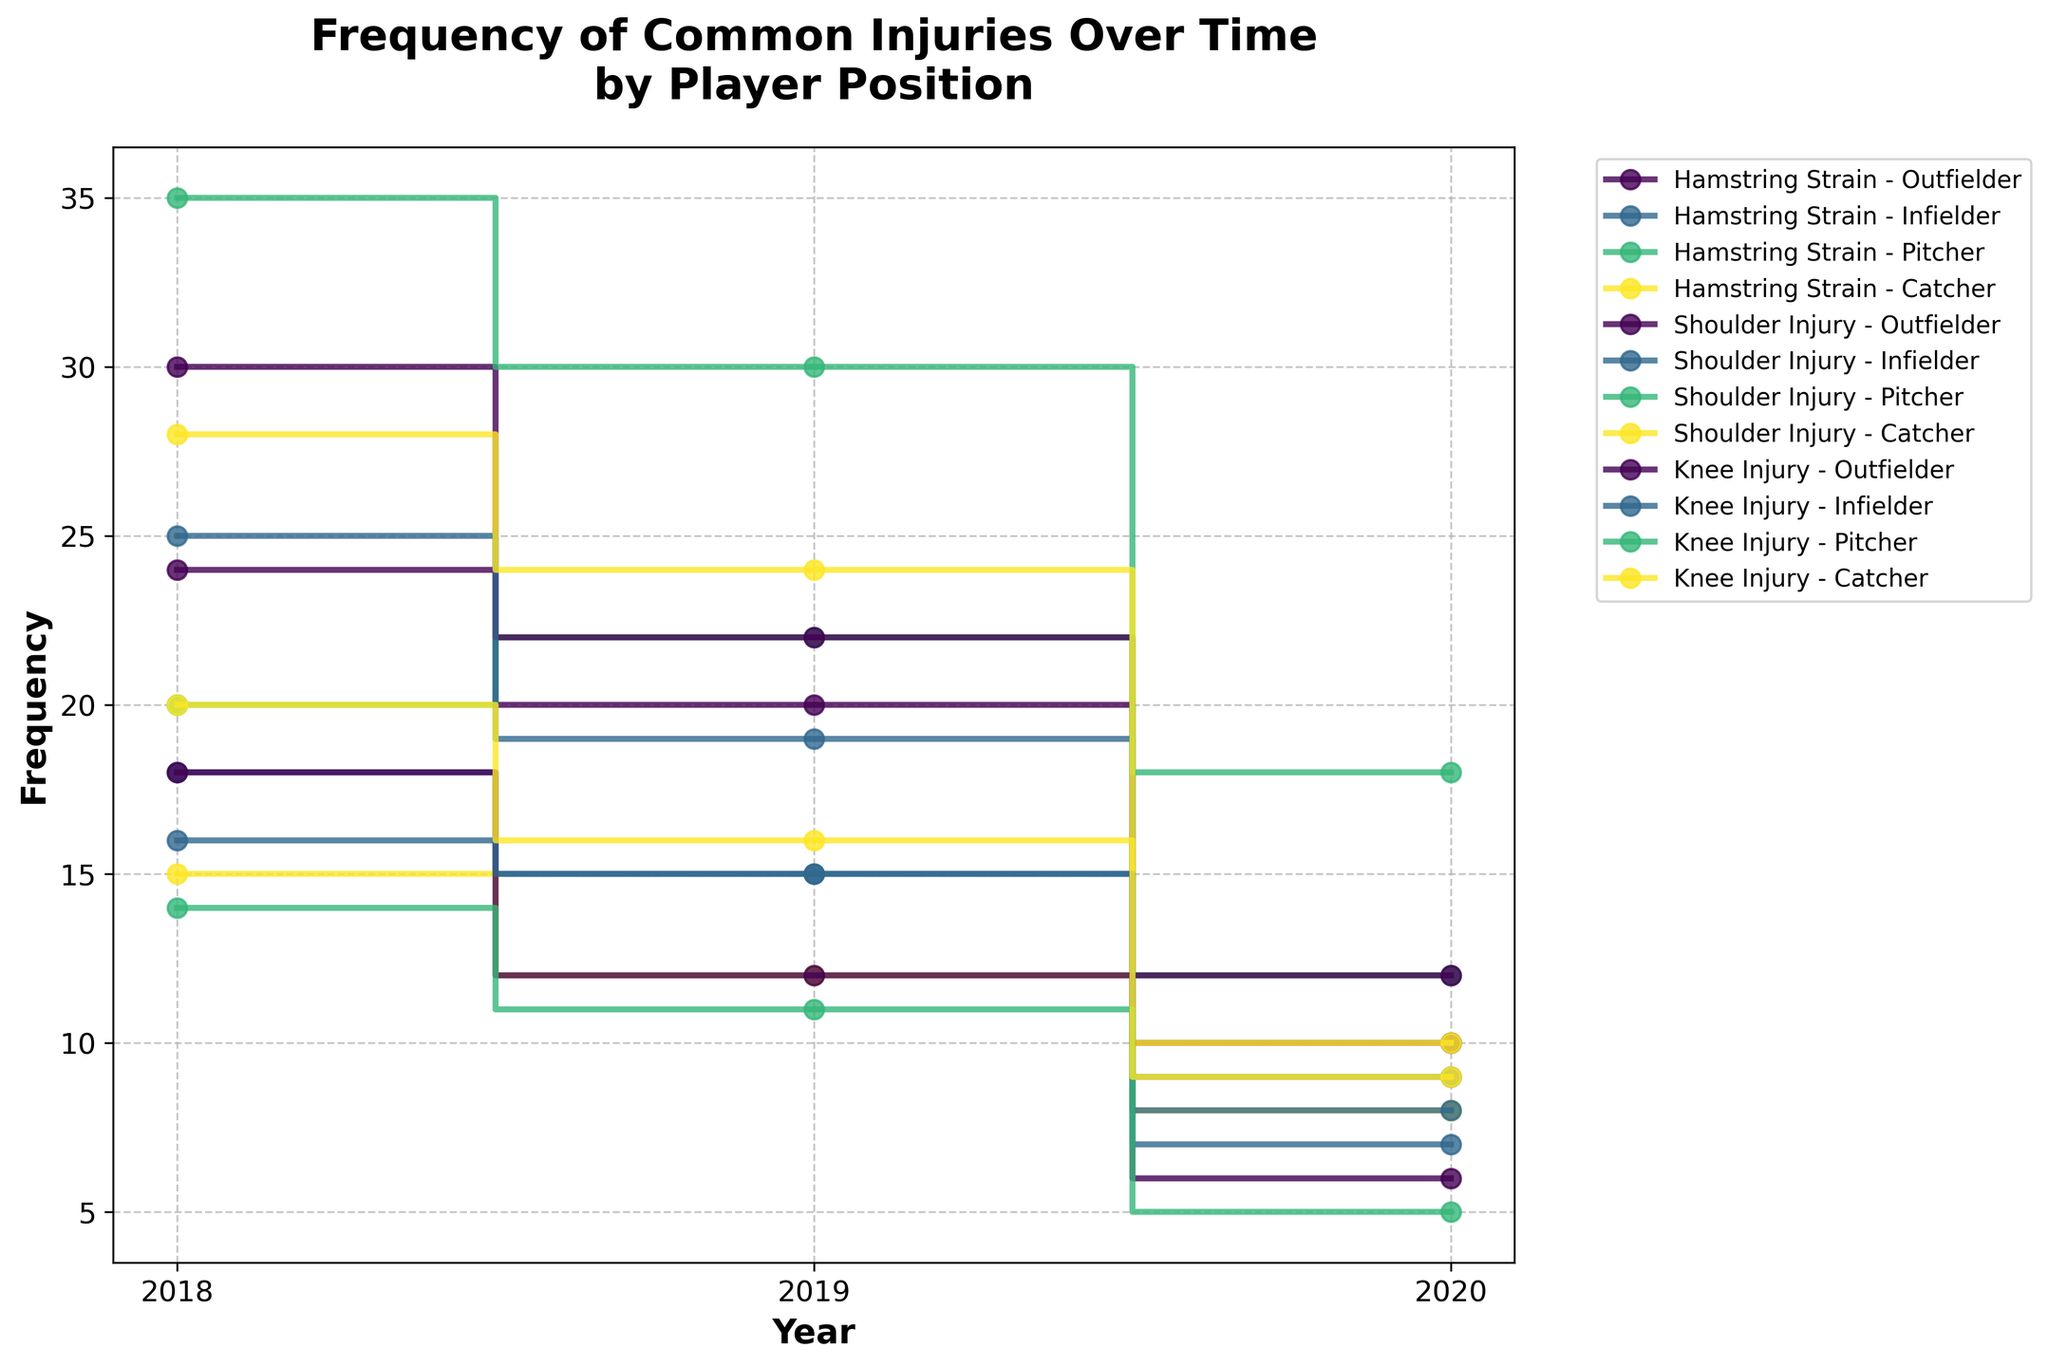What is the title of the figure? The title is written at the top of the figure and usually provides a summary of what the plot is about. The title in this figure reads 'Frequency of Common Injuries Over Time by Player Position'.
Answer: Frequency of Common Injuries Over Time by Player Position Which injury type had the highest frequency in 2018 for pitchers? To determine this, look at the highest point on the y-axis for pitchers (marked in the legend) over the year 2018. The data shows the highest value for shoulder injury in 2018 for pitchers.
Answer: Shoulder Injury What is the frequency difference for hamstring strains in 2018 between outfielders and catchers? First, find the frequency values for hamstring strains for both outfielders and catchers in 2018. The frequencies are 24 for outfielders and 15 for catchers. The difference is 24 - 15.
Answer: 9 Which player position had the lowest frequency of knee injuries in 2020? Locate the knee injury data for 2020 and compare the values for each position. Pitchers have the lowest frequency at 5.
Answer: Pitcher By how much did shoulder injuries for infielders decrease from 2018 to 2020? Find the frequency of shoulder injuries for infielders in 2018 and 2020. The values are 25 in 2018 and 8 in 2020. Calculate the decrease by subtracting 8 from 25.
Answer: 17 Did the frequency of hamstring strains for outfielders increase or decrease from 2018 to 2019? Compare the frequencies for 2018 and 2019. In 2018 it was 24 and in 2019 it was 20. Since 20 is less than 24, the frequency decreased.
Answer: Decrease Identify the year with the highest total frequency of injuries for catchers. To determine this, sum the frequencies for each injury type across all years (2018, 2019, 2020) for catchers. The totals are highest in 2018.
Answer: 2018 In 2020, what was the total frequency of shoulder injuries across all player positions? Sum the frequencies of shoulder injuries for all player positions (Outfielder, Infielder, Pitcher, Catcher) for the year 2020. The values are 12 + 8 + 18 + 10, giving a total of 48.
Answer: 48 Which injury type experienced the most significant reduction in frequency for outfielders from 2018 to 2020? Calculate the differences in frequency for each injury type (hamstring strain, shoulder injury, knee injury) for outfielders from 2018 to 2020. The largest reduction is for shoulder injuries, from 30 to 12.
Answer: Shoulder Injury 